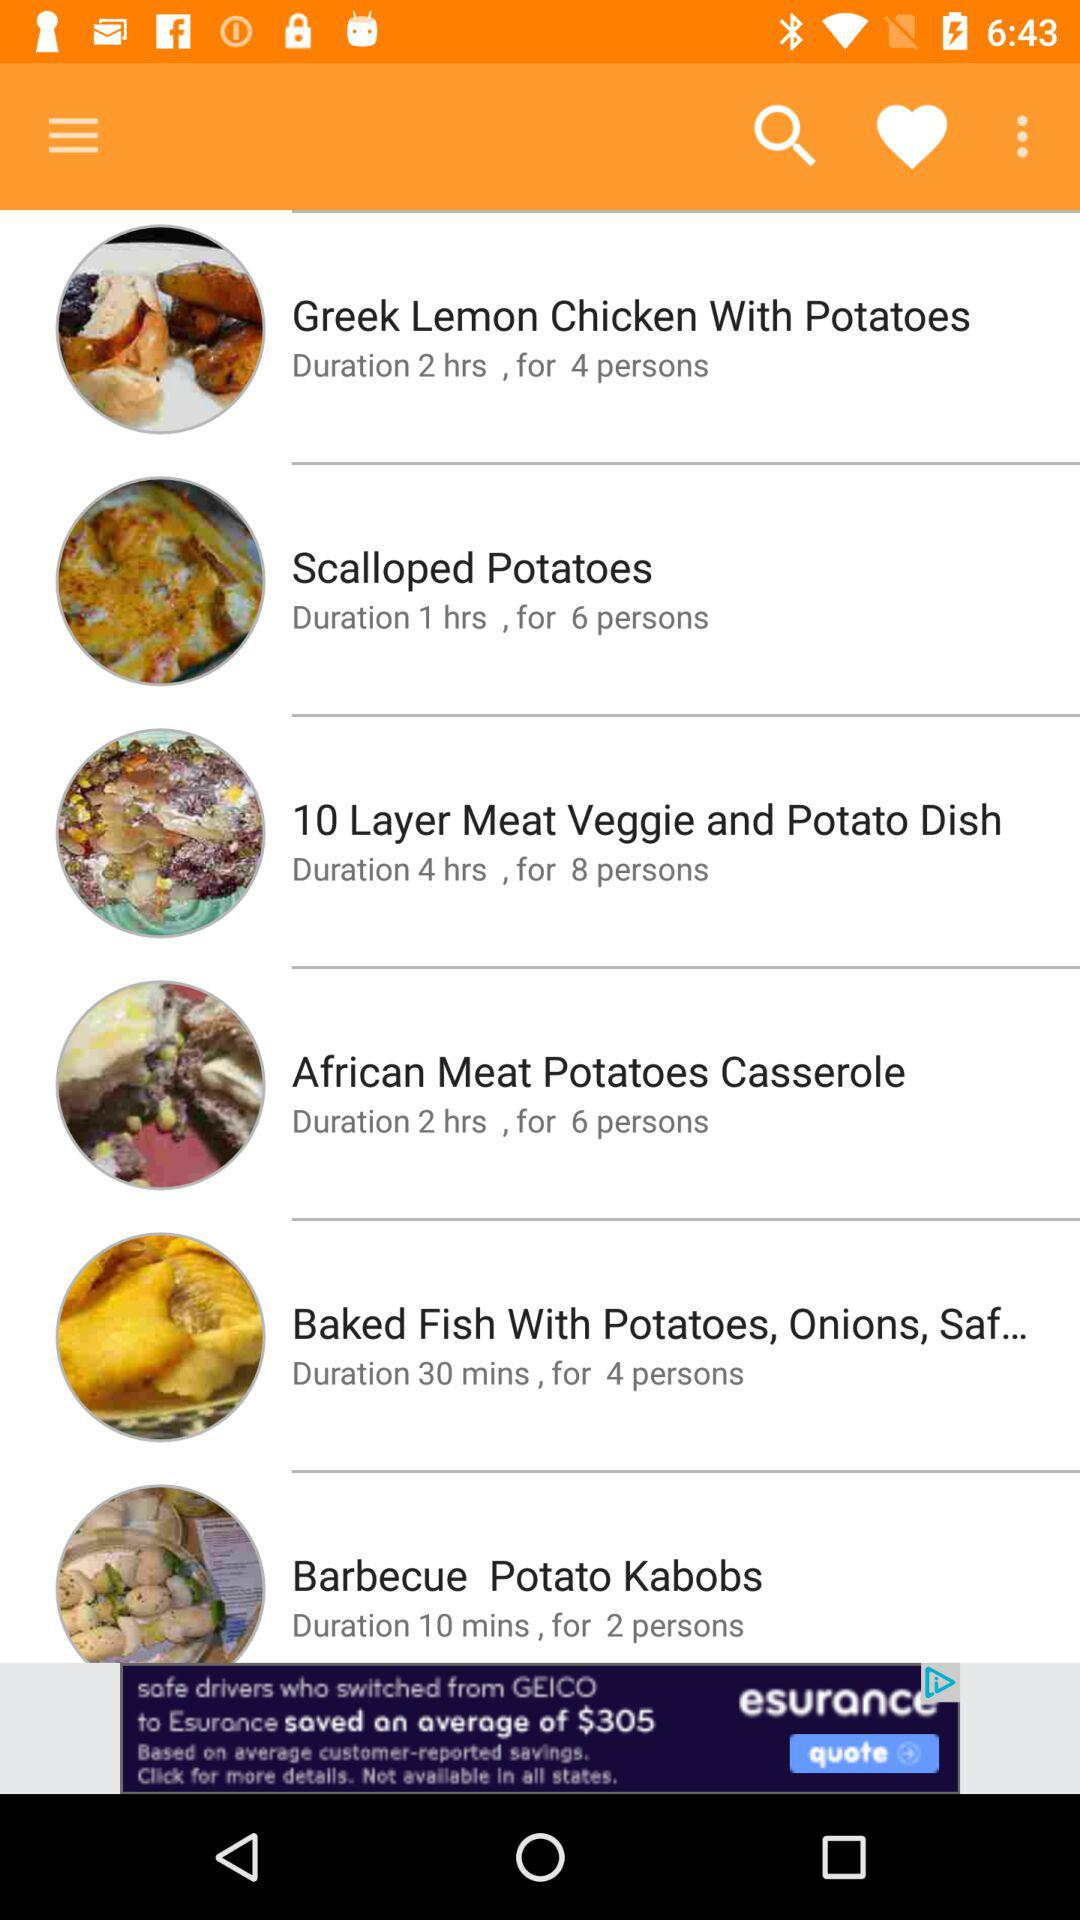What is the duration of "Scalloped Potatoes"? The duration is 1 hour. 